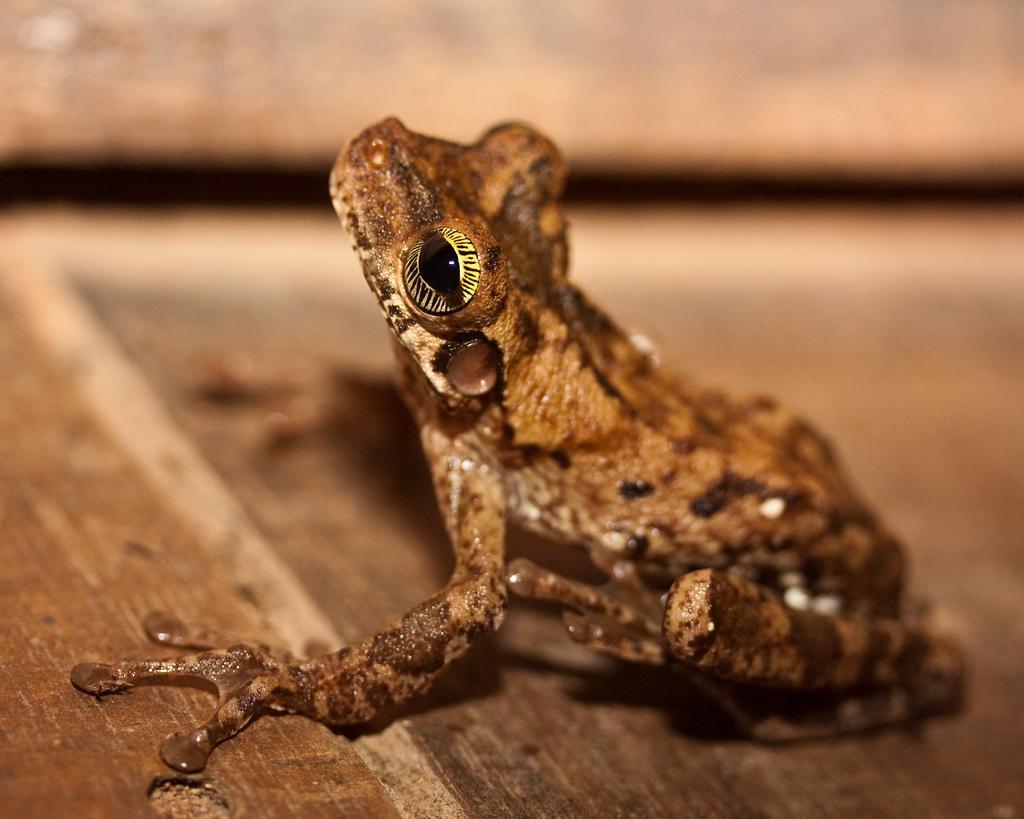Describe this image in one or two sentences. In the center of the image there is a frog on the floor. 